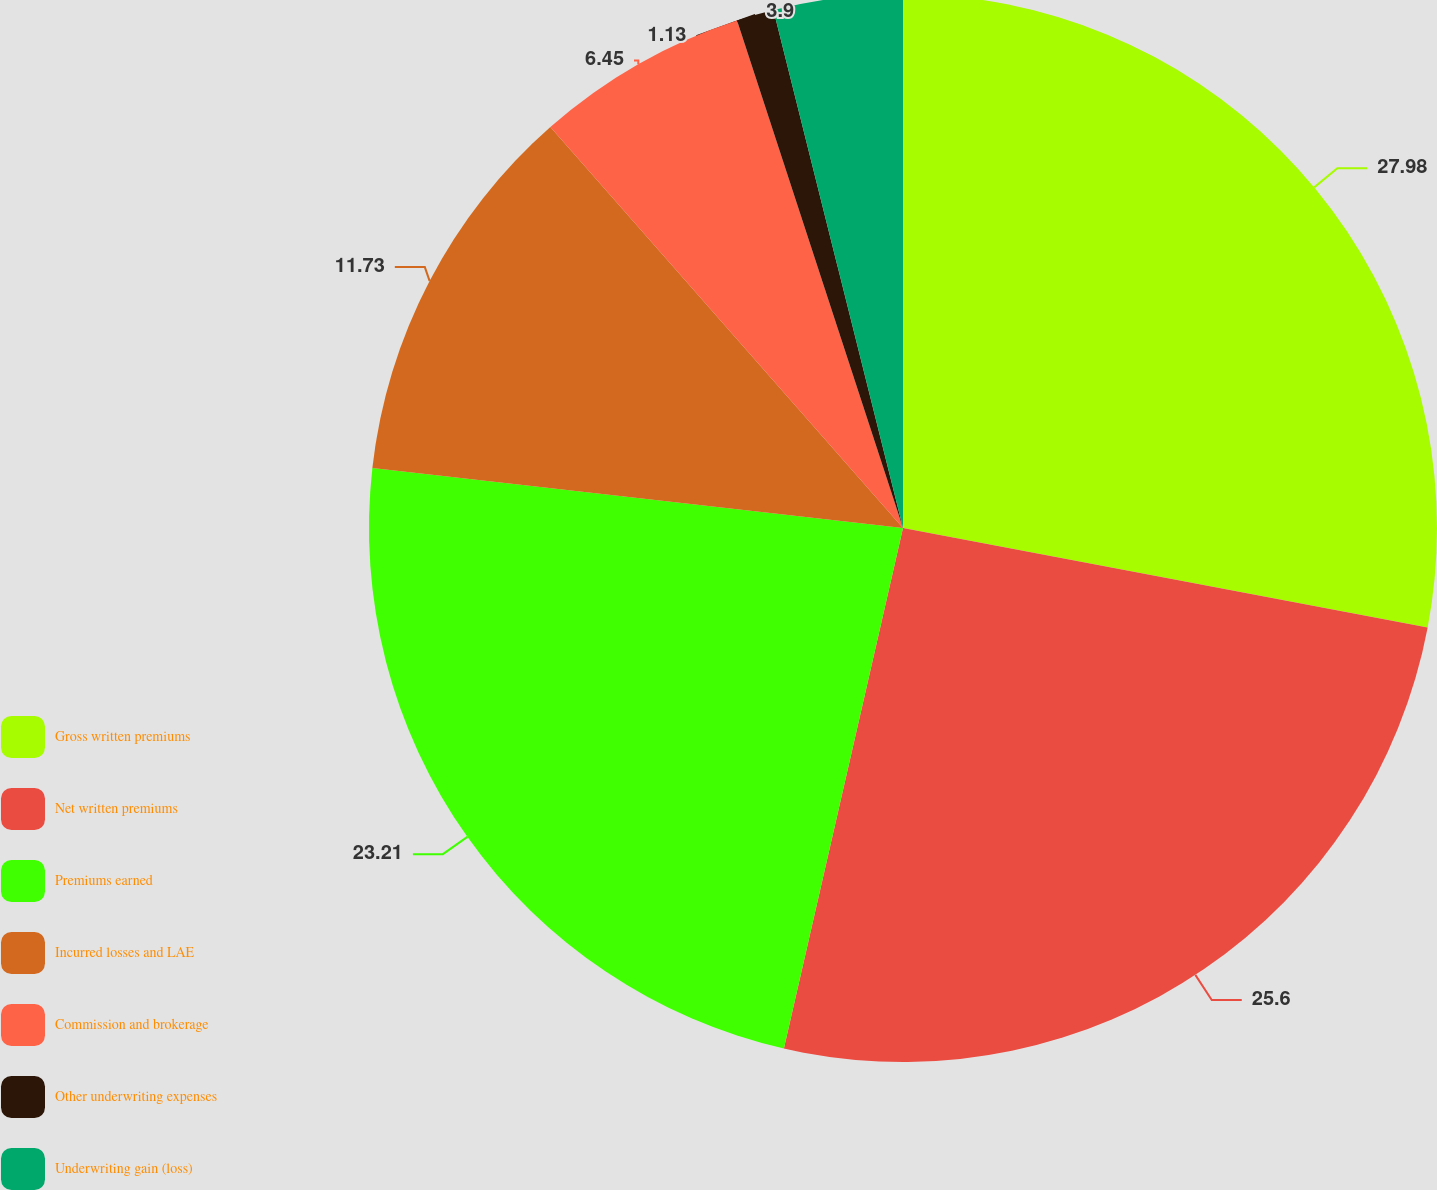Convert chart. <chart><loc_0><loc_0><loc_500><loc_500><pie_chart><fcel>Gross written premiums<fcel>Net written premiums<fcel>Premiums earned<fcel>Incurred losses and LAE<fcel>Commission and brokerage<fcel>Other underwriting expenses<fcel>Underwriting gain (loss)<nl><fcel>27.98%<fcel>25.6%<fcel>23.21%<fcel>11.73%<fcel>6.45%<fcel>1.13%<fcel>3.9%<nl></chart> 